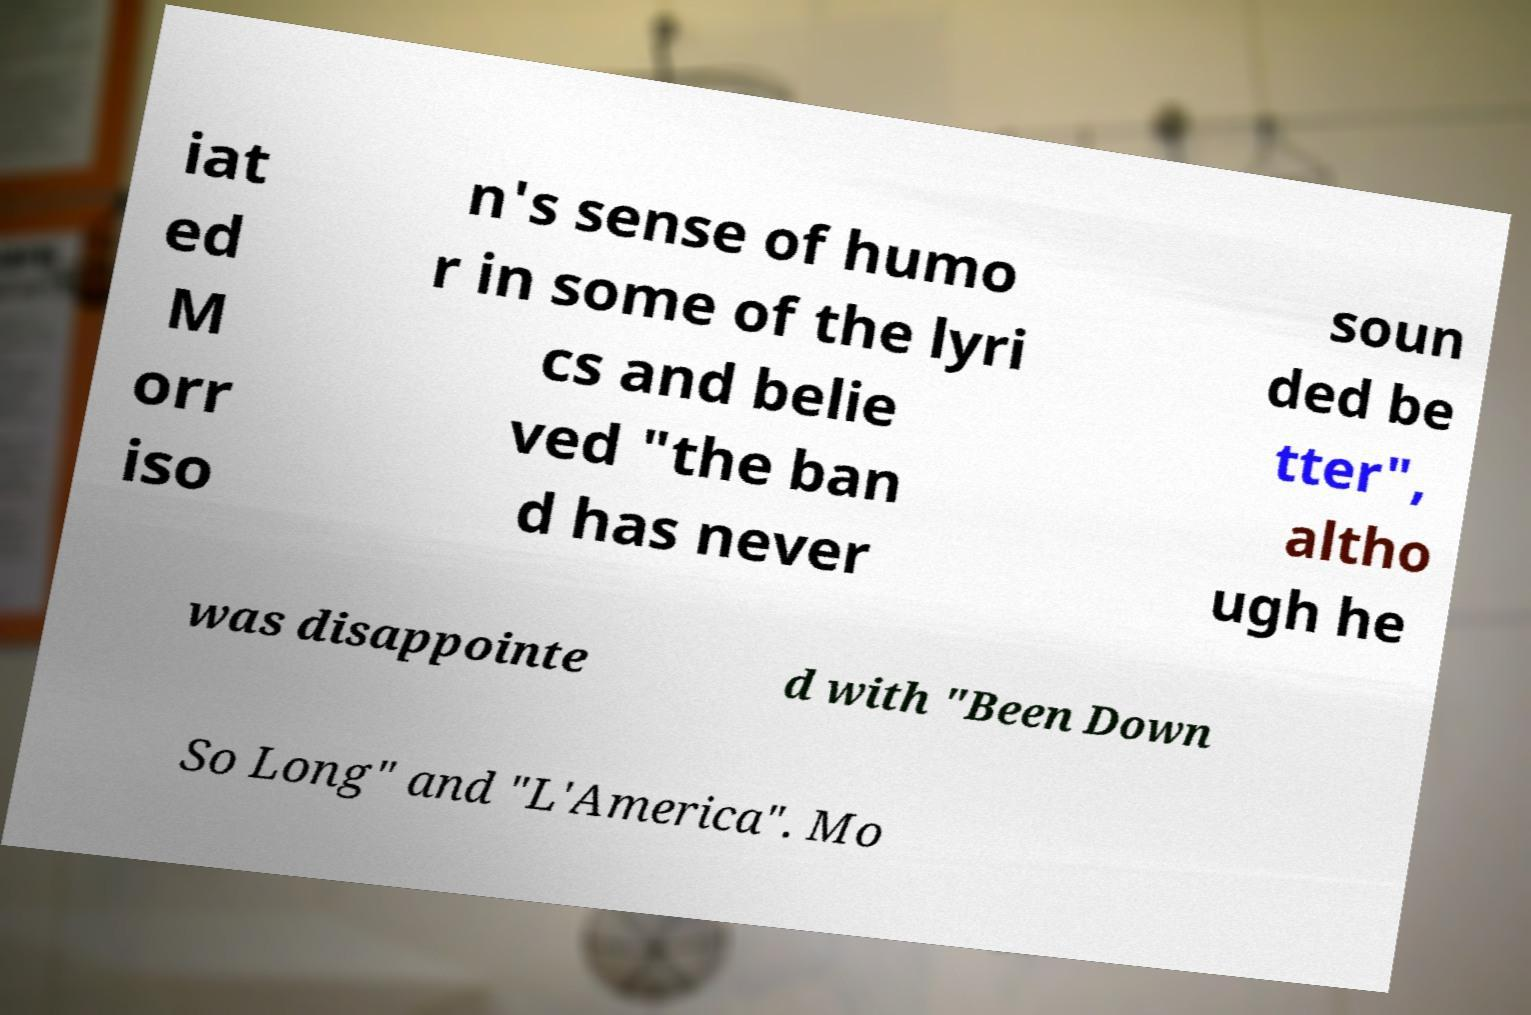Can you accurately transcribe the text from the provided image for me? iat ed M orr iso n's sense of humo r in some of the lyri cs and belie ved "the ban d has never soun ded be tter", altho ugh he was disappointe d with "Been Down So Long" and "L'America". Mo 